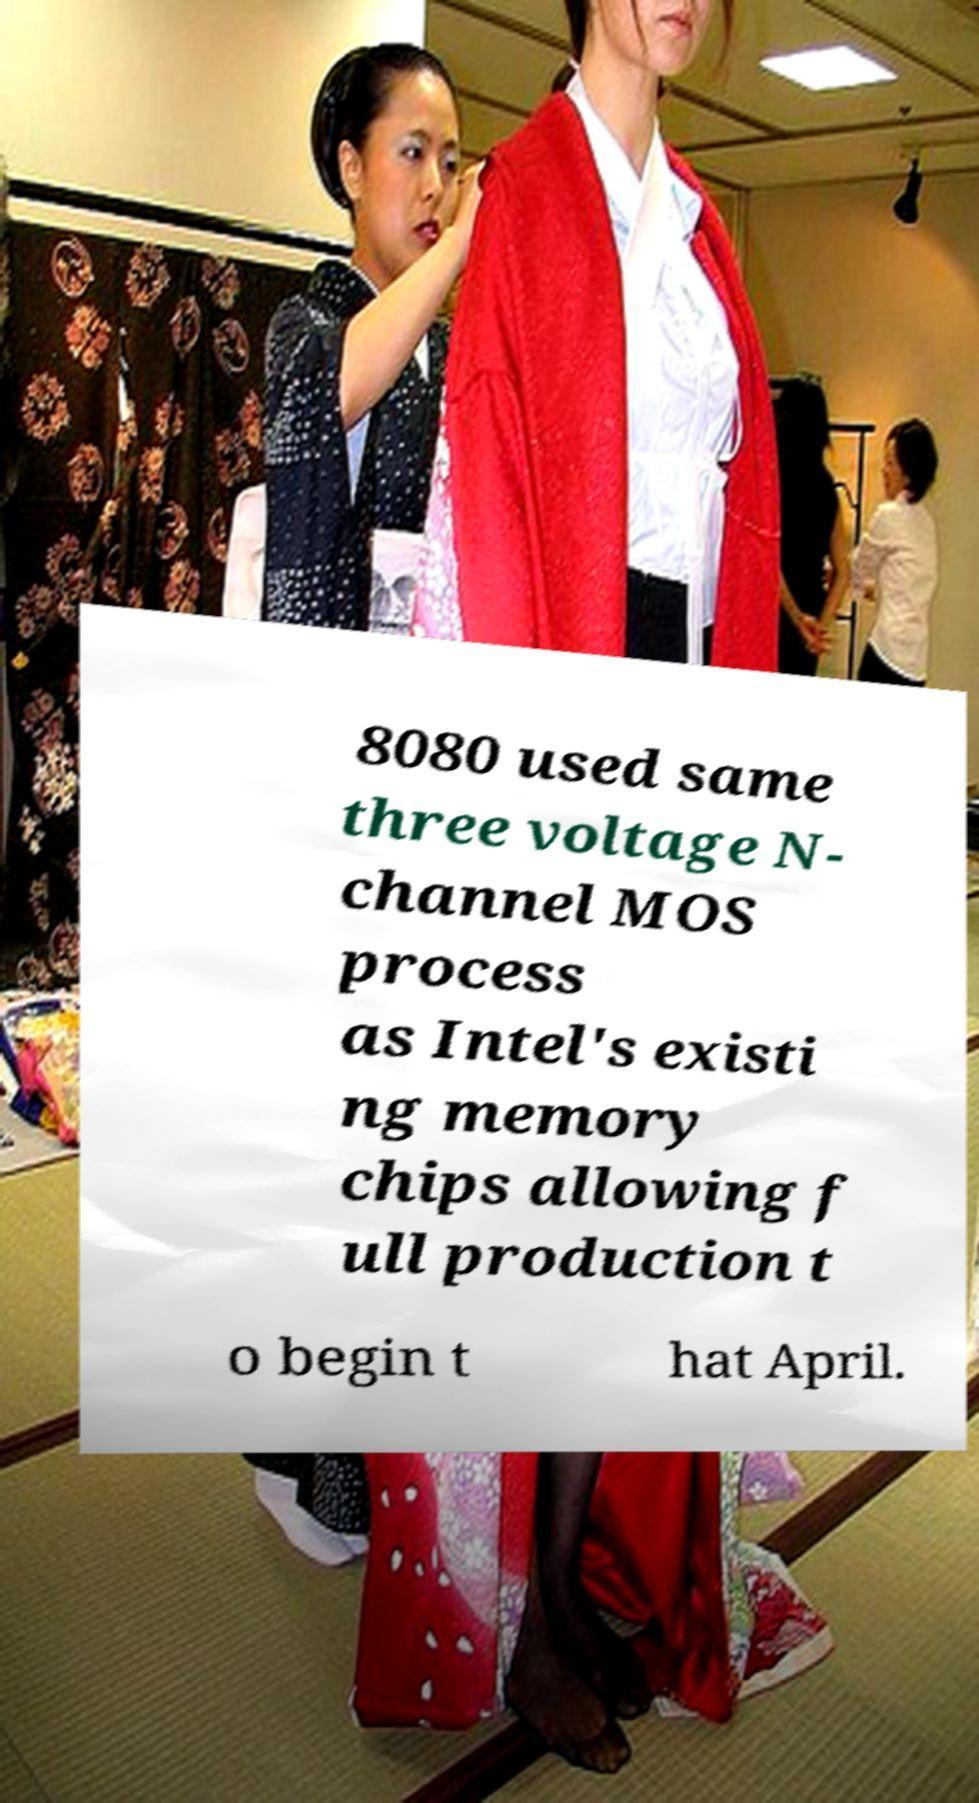What messages or text are displayed in this image? I need them in a readable, typed format. 8080 used same three voltage N- channel MOS process as Intel's existi ng memory chips allowing f ull production t o begin t hat April. 